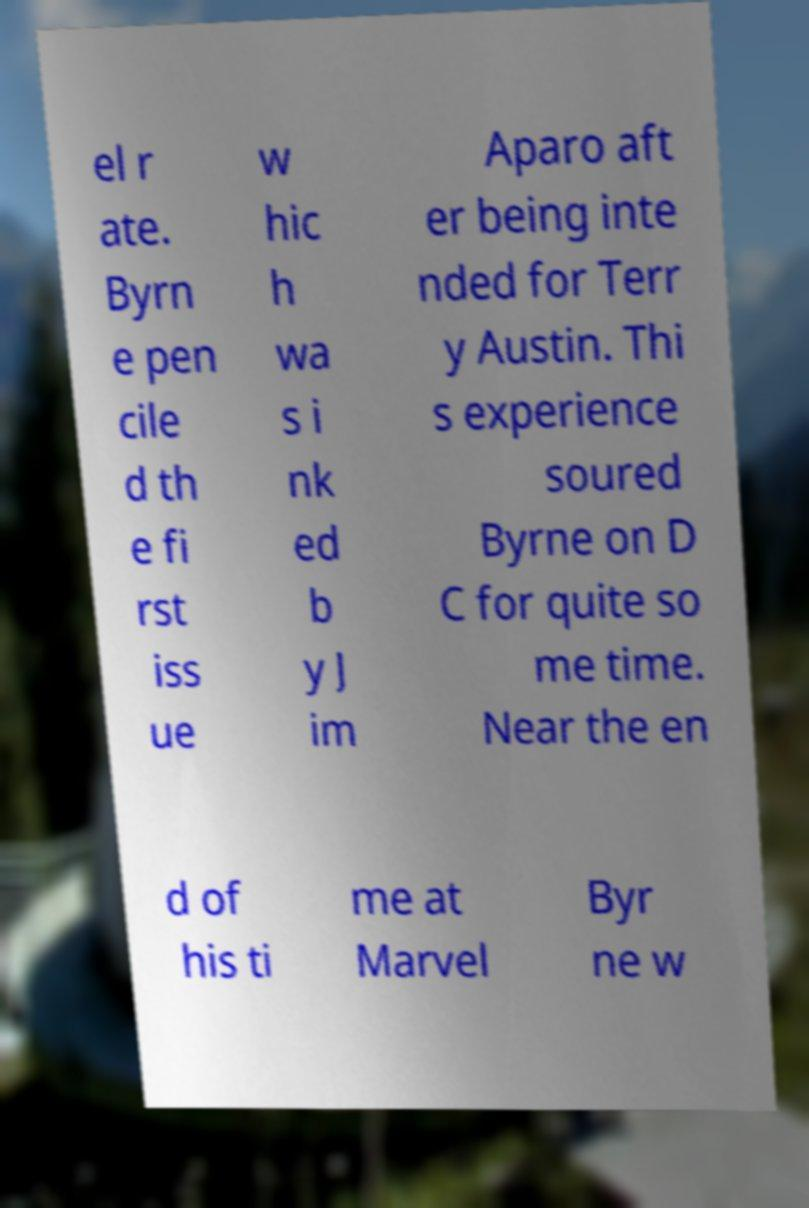Could you assist in decoding the text presented in this image and type it out clearly? el r ate. Byrn e pen cile d th e fi rst iss ue w hic h wa s i nk ed b y J im Aparo aft er being inte nded for Terr y Austin. Thi s experience soured Byrne on D C for quite so me time. Near the en d of his ti me at Marvel Byr ne w 